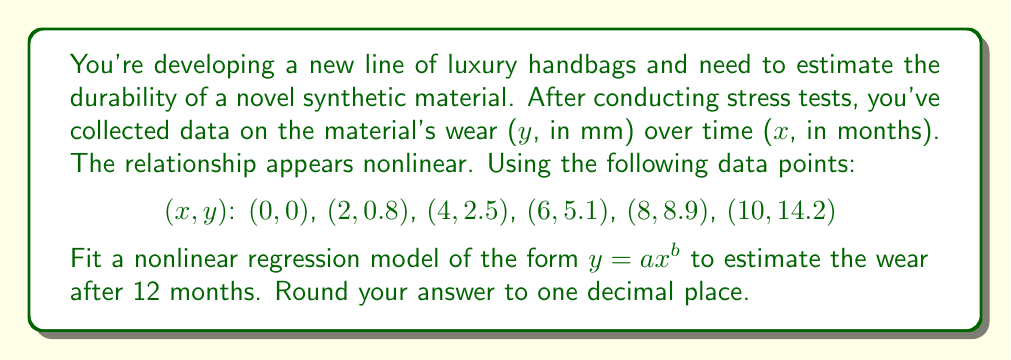Could you help me with this problem? To solve this problem, we'll use nonlinear regression to fit the model $y = ax^b$ to the given data points. We'll use the logarithmic transformation method to linearize the equation and then use linear regression techniques.

Step 1: Transform the equation
Let $Y = \ln(y)$ and $X = \ln(x)$
Then $\ln(y) = \ln(ax^b) = \ln(a) + b\ln(x)$
So, $Y = \ln(a) + bX$

Step 2: Transform the data points
(Ignore the point (0, 0) as ln(0) is undefined)
X = ln(x): (0.693, 1.386, 1.792, 2.079, 2.303)
Y = ln(y): (-0.223, 0.916, 1.629, 2.186, 2.653)

Step 3: Perform linear regression on (X, Y)
Using the least squares method:
$b = \frac{n\sum XY - \sum X \sum Y}{n\sum X^2 - (\sum X)^2}$
$\ln(a) = \bar{Y} - b\bar{X}$

Calculating the sums:
$\sum X = 8.253$, $\sum Y = 7.161$, $\sum XY = 13.604$, $\sum X^2 = 14.979$
$n = 5$

$b = \frac{5(13.604) - (8.253)(7.161)}{5(14.979) - (8.253)^2} = 2.062$

$\ln(a) = \frac{7.161}{5} - 2.062(\frac{8.253}{5}) = -1.384$

$a = e^{-1.384} = 0.251$

Step 4: Write the fitted model
$y = 0.251x^{2.062}$

Step 5: Estimate wear at 12 months
$y = 0.251(12)^{2.062} = 20.7$ mm

Rounding to one decimal place: 20.7 mm
Answer: 20.7 mm 